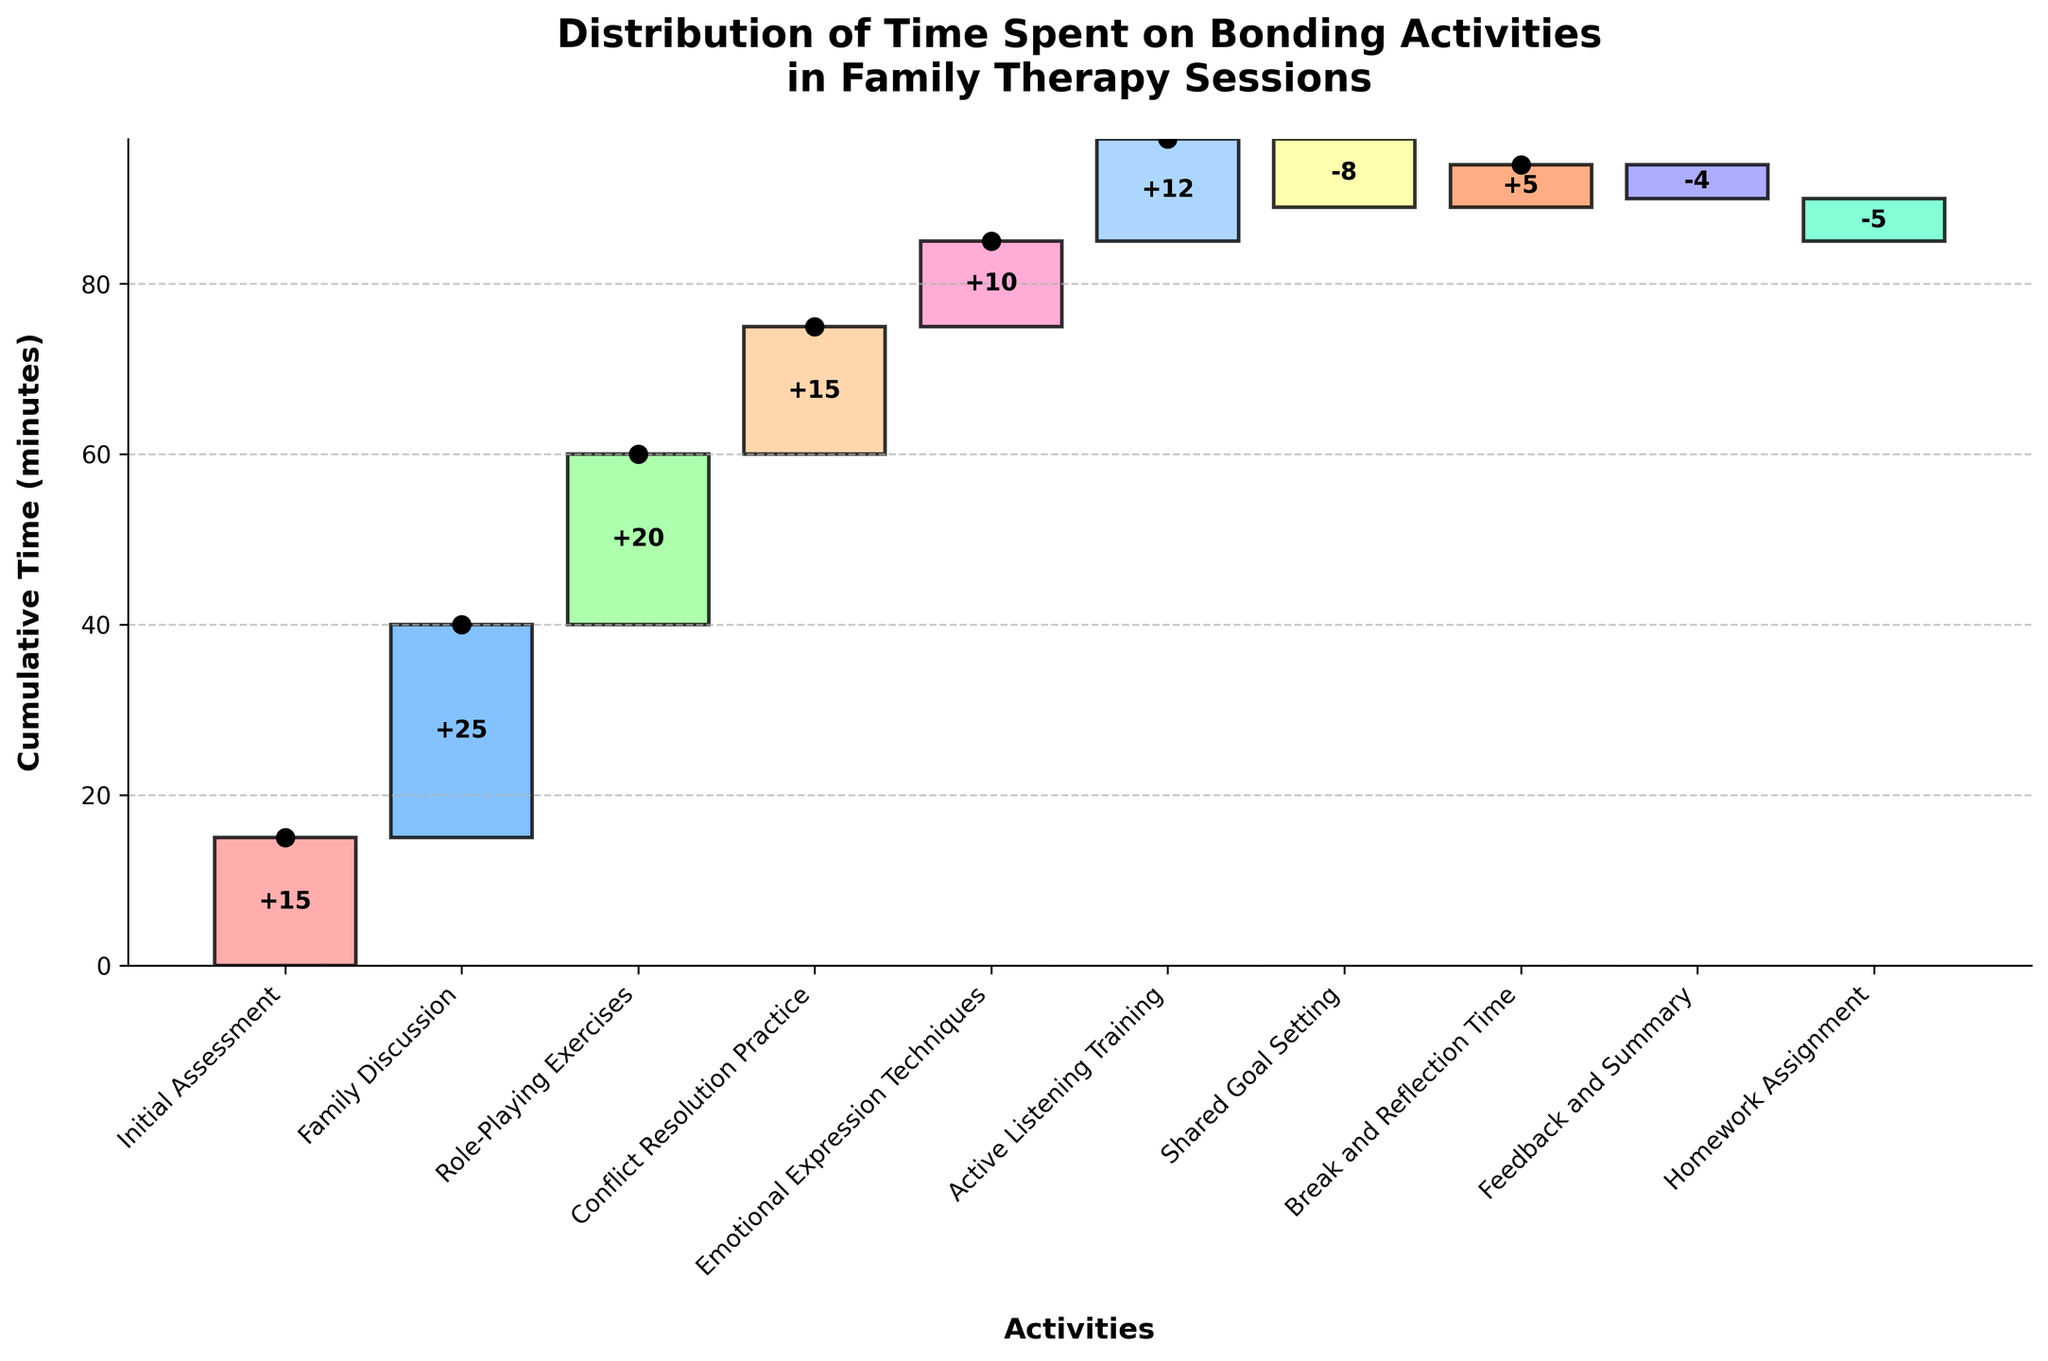What is the title of the chart? The title of the chart can be directly seen at the top of the figure, which provides the main topic of the visualization.
Answer: Distribution of Time Spent on Bonding Activities in Family Therapy Sessions How many activities are represented in the chart? The number of bars in the chart corresponds to the number of activities represented. Count each bar to find the total number.
Answer: 10 Which activity has the highest time allocation? Identify the tallest bar in the chart, as it represents the activity with the highest time allocation.
Answer: Family Discussion What is the cumulative time after Role-Playing Exercises? To find the cumulative time after the Role-Playing Exercises, sum the times from Initial Assessment to Role-Playing Exercises. Initial Assessment (15) + Family Discussion (25) + Role-Playing Exercises (20) = 60 minutes.
Answer: 60 minutes What activities result in a decrease in cumulative time? Activities that result in a decrease will have bars extending downward and have a '-' sign next to their value.
Answer: Shared Goal Setting, Feedback and Summary, Homework Assignment Compare the time allocated to Active Listening Training and Conflict Resolution Practice. Which one is greater? Look at the heights of the bars corresponding to Active Listening Training and Conflict Resolution Practice. The bar with a larger height denotes the activity with greater time.
Answer: Conflict Resolution Practice Which activity's bar is colored with a unique orange hue, and what is its time allocation? Identify the bar with the unique orange color and read its allocated time from the labeled value on the bar.
Answer: Break and Reflection Time, 5 minutes Calculate the total time reduction from activities that decrease the cumulative time. Sum the times of the activities that cause a decrease: Shared Goal Setting (-8) + Feedback and Summary (-4) + Homework Assignment (-5) = -17 minutes.
Answer: -17 minutes How does the cumulative time change from Emotional Expression Techniques to Active Listening Training? Calculate the cumulative time at Emotional Expression Techniques and then at Active Listening Training, then find the difference. Before Emotional Expression Techniques: Initial (15) + Discussion (25) + Role-Playing (20) = 60 + Conflict (15) = 75 + Emotional (10) = 85. After Active Listening: +12 = 97. Difference: 97-85 = 12 minutes.
Answer: +12 minutes What is the final cumulative time at the end of the session after Homework Assignment? Add up all individual time allocations starting from the first to the last activity, ensuring to account for any negative values as well. Calculation: 15+25+20+15+10+12-8+5-4-5 = 85.
Answer: 85 minutes 